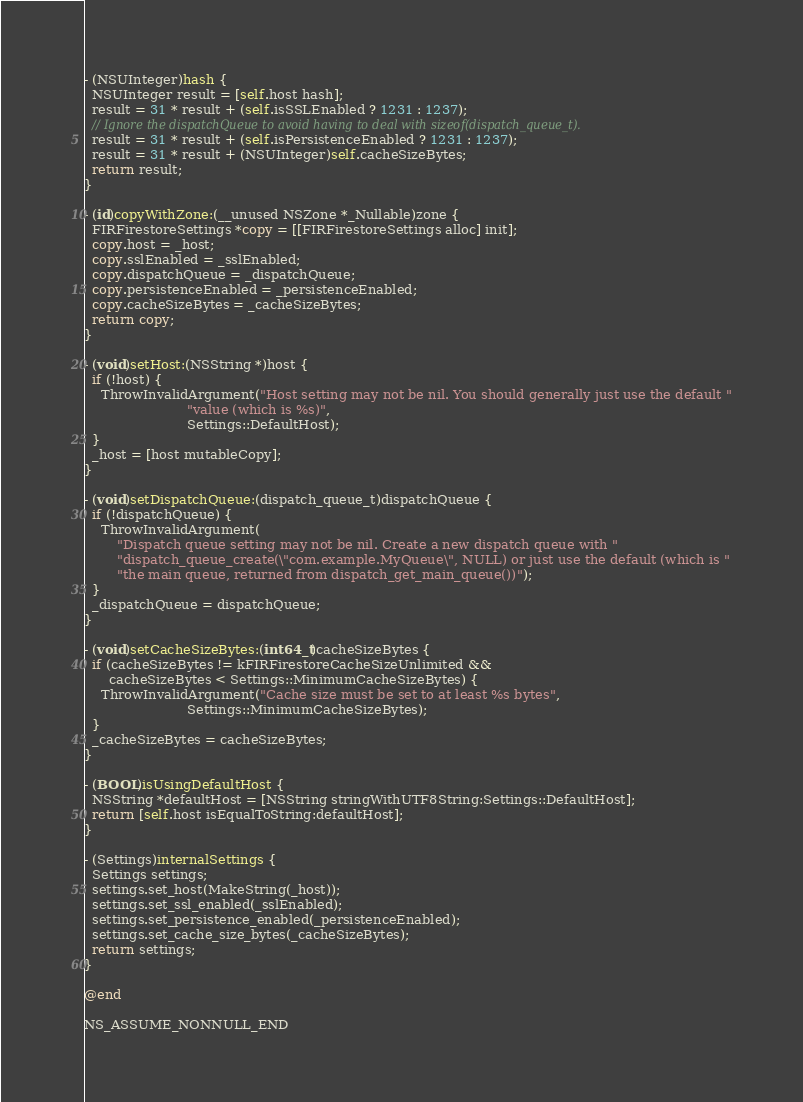<code> <loc_0><loc_0><loc_500><loc_500><_ObjectiveC_>- (NSUInteger)hash {
  NSUInteger result = [self.host hash];
  result = 31 * result + (self.isSSLEnabled ? 1231 : 1237);
  // Ignore the dispatchQueue to avoid having to deal with sizeof(dispatch_queue_t).
  result = 31 * result + (self.isPersistenceEnabled ? 1231 : 1237);
  result = 31 * result + (NSUInteger)self.cacheSizeBytes;
  return result;
}

- (id)copyWithZone:(__unused NSZone *_Nullable)zone {
  FIRFirestoreSettings *copy = [[FIRFirestoreSettings alloc] init];
  copy.host = _host;
  copy.sslEnabled = _sslEnabled;
  copy.dispatchQueue = _dispatchQueue;
  copy.persistenceEnabled = _persistenceEnabled;
  copy.cacheSizeBytes = _cacheSizeBytes;
  return copy;
}

- (void)setHost:(NSString *)host {
  if (!host) {
    ThrowInvalidArgument("Host setting may not be nil. You should generally just use the default "
                         "value (which is %s)",
                         Settings::DefaultHost);
  }
  _host = [host mutableCopy];
}

- (void)setDispatchQueue:(dispatch_queue_t)dispatchQueue {
  if (!dispatchQueue) {
    ThrowInvalidArgument(
        "Dispatch queue setting may not be nil. Create a new dispatch queue with "
        "dispatch_queue_create(\"com.example.MyQueue\", NULL) or just use the default (which is "
        "the main queue, returned from dispatch_get_main_queue())");
  }
  _dispatchQueue = dispatchQueue;
}

- (void)setCacheSizeBytes:(int64_t)cacheSizeBytes {
  if (cacheSizeBytes != kFIRFirestoreCacheSizeUnlimited &&
      cacheSizeBytes < Settings::MinimumCacheSizeBytes) {
    ThrowInvalidArgument("Cache size must be set to at least %s bytes",
                         Settings::MinimumCacheSizeBytes);
  }
  _cacheSizeBytes = cacheSizeBytes;
}

- (BOOL)isUsingDefaultHost {
  NSString *defaultHost = [NSString stringWithUTF8String:Settings::DefaultHost];
  return [self.host isEqualToString:defaultHost];
}

- (Settings)internalSettings {
  Settings settings;
  settings.set_host(MakeString(_host));
  settings.set_ssl_enabled(_sslEnabled);
  settings.set_persistence_enabled(_persistenceEnabled);
  settings.set_cache_size_bytes(_cacheSizeBytes);
  return settings;
}

@end

NS_ASSUME_NONNULL_END
</code> 